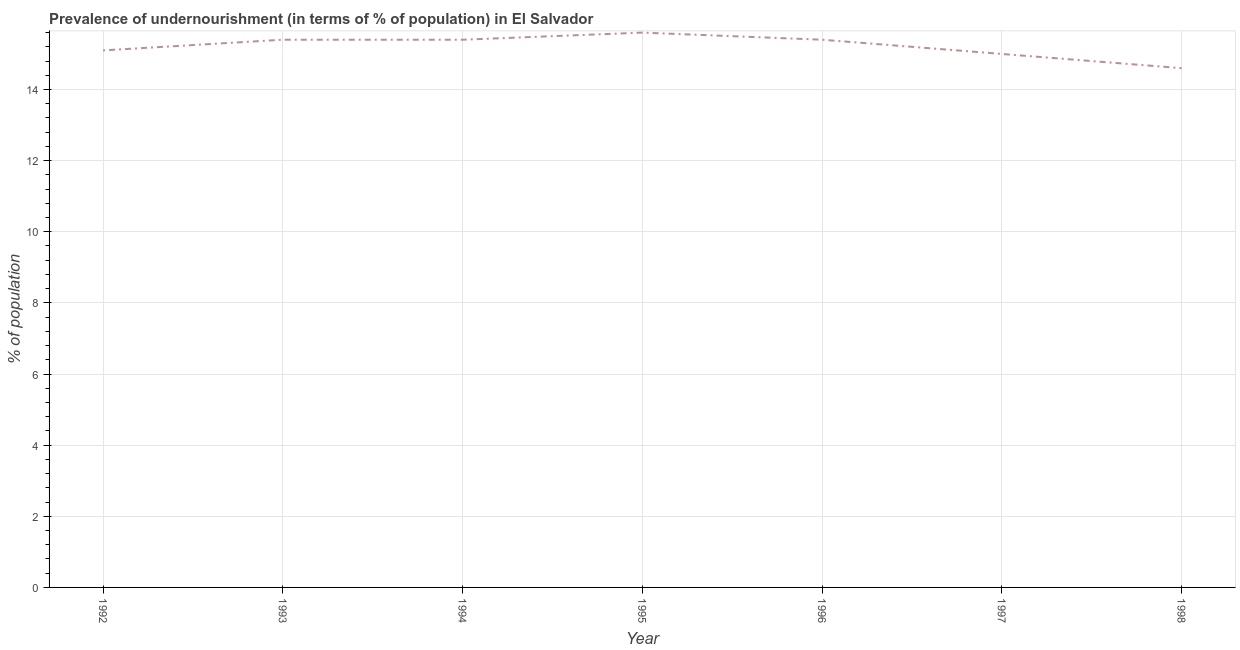In which year was the percentage of undernourished population maximum?
Keep it short and to the point. 1995. In which year was the percentage of undernourished population minimum?
Make the answer very short. 1998. What is the sum of the percentage of undernourished population?
Your response must be concise. 106.5. What is the difference between the percentage of undernourished population in 1992 and 1994?
Offer a terse response. -0.3. What is the average percentage of undernourished population per year?
Offer a very short reply. 15.21. Do a majority of the years between 1998 and 1994 (inclusive) have percentage of undernourished population greater than 14.4 %?
Give a very brief answer. Yes. What is the ratio of the percentage of undernourished population in 1992 to that in 1995?
Ensure brevity in your answer.  0.97. Is the difference between the percentage of undernourished population in 1994 and 1996 greater than the difference between any two years?
Provide a short and direct response. No. What is the difference between the highest and the second highest percentage of undernourished population?
Provide a succinct answer. 0.2. How many years are there in the graph?
Make the answer very short. 7. What is the difference between two consecutive major ticks on the Y-axis?
Your answer should be very brief. 2. Does the graph contain any zero values?
Offer a very short reply. No. Does the graph contain grids?
Provide a succinct answer. Yes. What is the title of the graph?
Provide a succinct answer. Prevalence of undernourishment (in terms of % of population) in El Salvador. What is the label or title of the X-axis?
Provide a succinct answer. Year. What is the label or title of the Y-axis?
Your answer should be compact. % of population. What is the % of population of 1994?
Make the answer very short. 15.4. What is the % of population of 1995?
Ensure brevity in your answer.  15.6. What is the % of population of 1997?
Provide a succinct answer. 15. What is the % of population in 1998?
Your response must be concise. 14.6. What is the difference between the % of population in 1992 and 1995?
Ensure brevity in your answer.  -0.5. What is the difference between the % of population in 1992 and 1997?
Keep it short and to the point. 0.1. What is the difference between the % of population in 1992 and 1998?
Keep it short and to the point. 0.5. What is the difference between the % of population in 1993 and 1994?
Your answer should be compact. 0. What is the difference between the % of population in 1995 and 1996?
Make the answer very short. 0.2. What is the difference between the % of population in 1995 and 1997?
Offer a terse response. 0.6. What is the difference between the % of population in 1996 and 1997?
Provide a succinct answer. 0.4. What is the difference between the % of population in 1997 and 1998?
Offer a terse response. 0.4. What is the ratio of the % of population in 1992 to that in 1993?
Your answer should be very brief. 0.98. What is the ratio of the % of population in 1992 to that in 1997?
Your answer should be very brief. 1.01. What is the ratio of the % of population in 1992 to that in 1998?
Your answer should be compact. 1.03. What is the ratio of the % of population in 1993 to that in 1995?
Your answer should be very brief. 0.99. What is the ratio of the % of population in 1993 to that in 1996?
Provide a succinct answer. 1. What is the ratio of the % of population in 1993 to that in 1998?
Offer a terse response. 1.05. What is the ratio of the % of population in 1994 to that in 1996?
Your answer should be compact. 1. What is the ratio of the % of population in 1994 to that in 1998?
Provide a succinct answer. 1.05. What is the ratio of the % of population in 1995 to that in 1996?
Your answer should be very brief. 1.01. What is the ratio of the % of population in 1995 to that in 1998?
Your answer should be compact. 1.07. What is the ratio of the % of population in 1996 to that in 1997?
Provide a short and direct response. 1.03. What is the ratio of the % of population in 1996 to that in 1998?
Your answer should be compact. 1.05. What is the ratio of the % of population in 1997 to that in 1998?
Give a very brief answer. 1.03. 